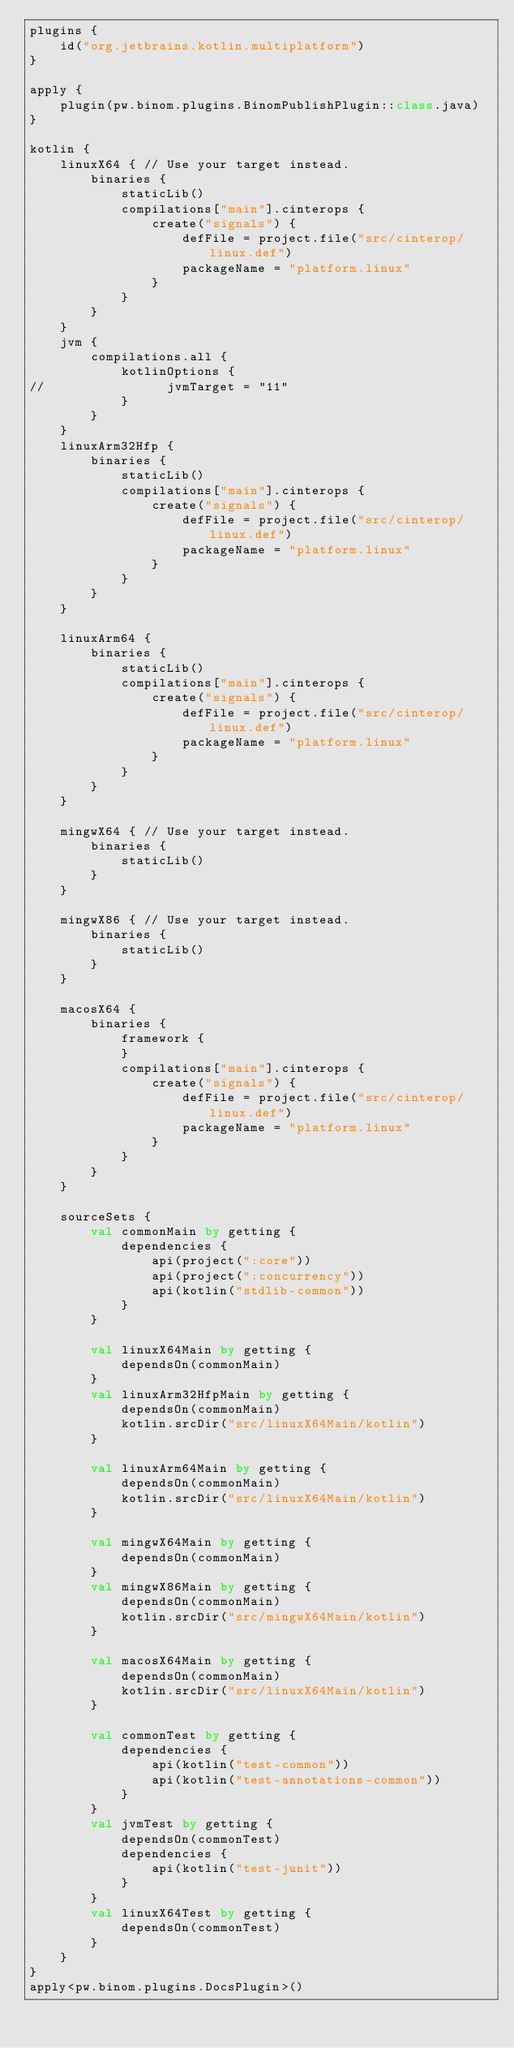Convert code to text. <code><loc_0><loc_0><loc_500><loc_500><_Kotlin_>plugins {
    id("org.jetbrains.kotlin.multiplatform")
}

apply {
    plugin(pw.binom.plugins.BinomPublishPlugin::class.java)
}

kotlin {
    linuxX64 { // Use your target instead.
        binaries {
            staticLib()
            compilations["main"].cinterops {
                create("signals") {
                    defFile = project.file("src/cinterop/linux.def")
                    packageName = "platform.linux"
                }
            }
        }
    }
    jvm {
        compilations.all {
            kotlinOptions {
//                jvmTarget = "11"
            }
        }
    }
    linuxArm32Hfp {
        binaries {
            staticLib()
            compilations["main"].cinterops {
                create("signals") {
                    defFile = project.file("src/cinterop/linux.def")
                    packageName = "platform.linux"
                }
            }
        }
    }

    linuxArm64 {
        binaries {
            staticLib()
            compilations["main"].cinterops {
                create("signals") {
                    defFile = project.file("src/cinterop/linux.def")
                    packageName = "platform.linux"
                }
            }
        }
    }

    mingwX64 { // Use your target instead.
        binaries {
            staticLib()
        }
    }

    mingwX86 { // Use your target instead.
        binaries {
            staticLib()
        }
    }

    macosX64 {
        binaries {
            framework {
            }
            compilations["main"].cinterops {
                create("signals") {
                    defFile = project.file("src/cinterop/linux.def")
                    packageName = "platform.linux"
                }
            }
        }
    }

    sourceSets {
        val commonMain by getting {
            dependencies {
                api(project(":core"))
                api(project(":concurrency"))
                api(kotlin("stdlib-common"))
            }
        }

        val linuxX64Main by getting {
            dependsOn(commonMain)
        }
        val linuxArm32HfpMain by getting {
            dependsOn(commonMain)
            kotlin.srcDir("src/linuxX64Main/kotlin")
        }

        val linuxArm64Main by getting {
            dependsOn(commonMain)
            kotlin.srcDir("src/linuxX64Main/kotlin")
        }

        val mingwX64Main by getting {
            dependsOn(commonMain)
        }
        val mingwX86Main by getting {
            dependsOn(commonMain)
            kotlin.srcDir("src/mingwX64Main/kotlin")
        }

        val macosX64Main by getting {
            dependsOn(commonMain)
            kotlin.srcDir("src/linuxX64Main/kotlin")
        }

        val commonTest by getting {
            dependencies {
                api(kotlin("test-common"))
                api(kotlin("test-annotations-common"))
            }
        }
        val jvmTest by getting {
            dependsOn(commonTest)
            dependencies {
                api(kotlin("test-junit"))
            }
        }
        val linuxX64Test by getting {
            dependsOn(commonTest)
        }
    }
}
apply<pw.binom.plugins.DocsPlugin>()</code> 